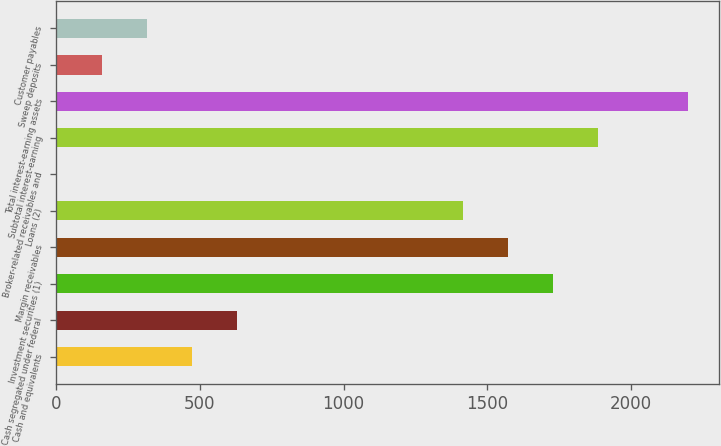<chart> <loc_0><loc_0><loc_500><loc_500><bar_chart><fcel>Cash and equivalents<fcel>Cash segregated under federal<fcel>Investment securities (1)<fcel>Margin receivables<fcel>Loans (2)<fcel>Broker-related receivables and<fcel>Subtotal interest-earning<fcel>Total interest-earning assets<fcel>Sweep deposits<fcel>Customer payables<nl><fcel>473.4<fcel>630.2<fcel>1727.8<fcel>1571<fcel>1414.2<fcel>3<fcel>1884.6<fcel>2198.2<fcel>159.8<fcel>316.6<nl></chart> 